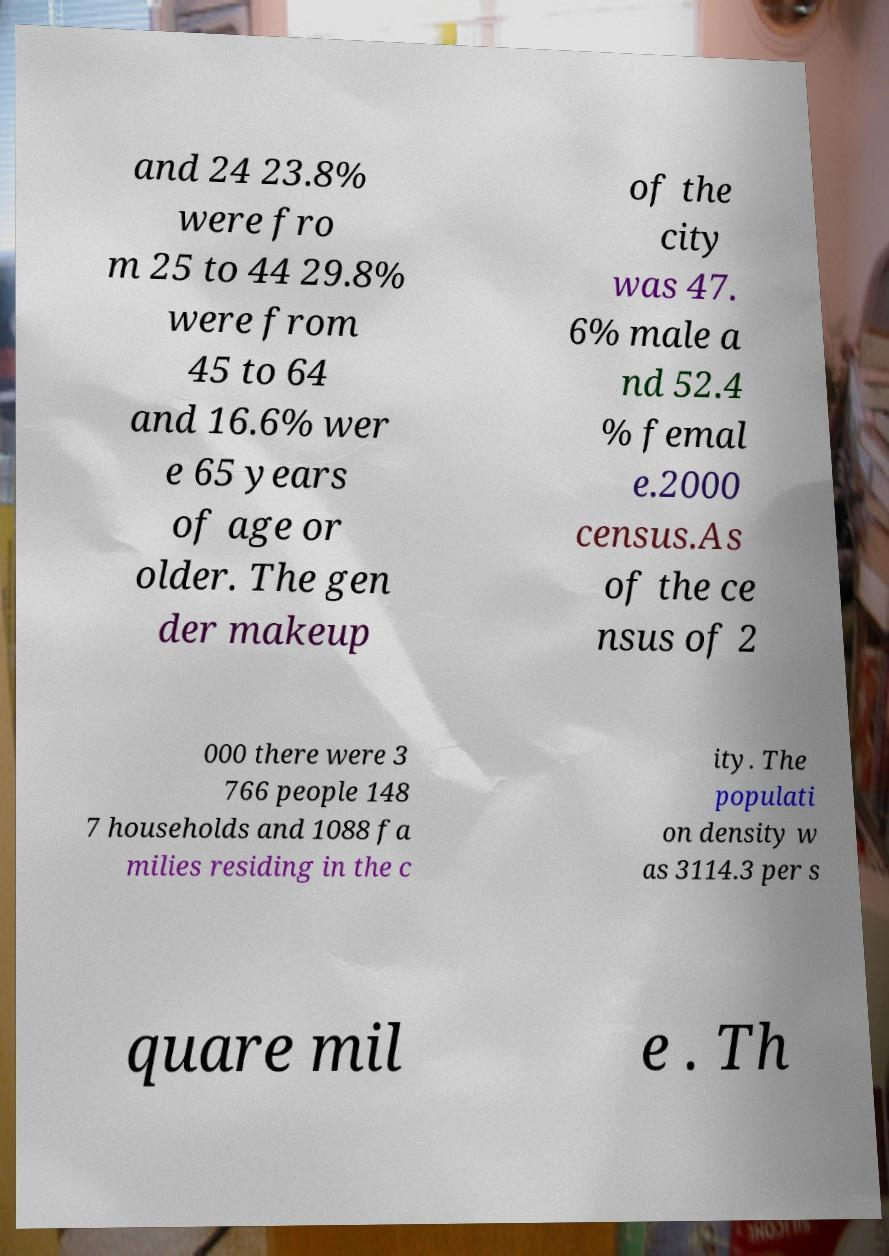For documentation purposes, I need the text within this image transcribed. Could you provide that? and 24 23.8% were fro m 25 to 44 29.8% were from 45 to 64 and 16.6% wer e 65 years of age or older. The gen der makeup of the city was 47. 6% male a nd 52.4 % femal e.2000 census.As of the ce nsus of 2 000 there were 3 766 people 148 7 households and 1088 fa milies residing in the c ity. The populati on density w as 3114.3 per s quare mil e . Th 